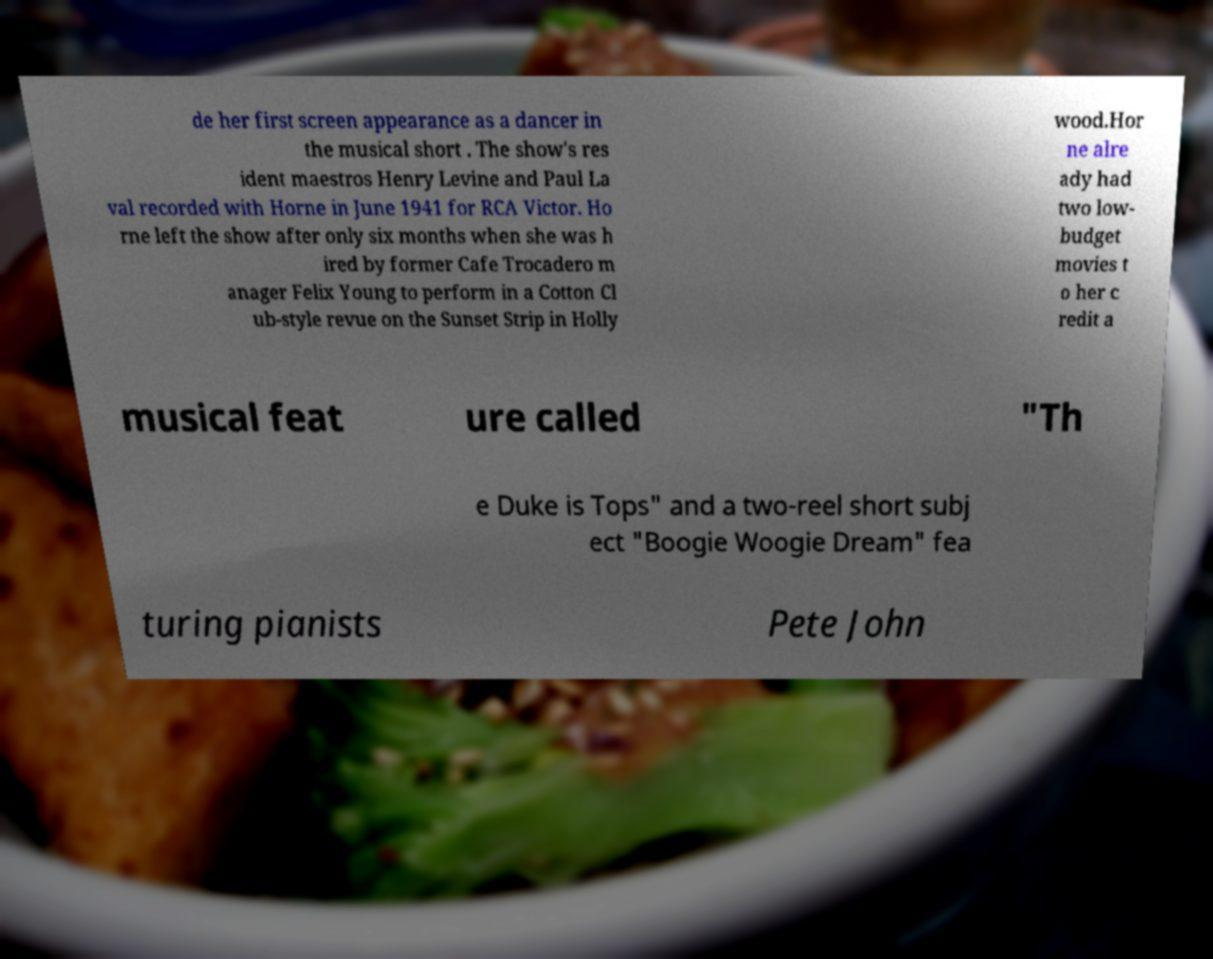I need the written content from this picture converted into text. Can you do that? de her first screen appearance as a dancer in the musical short . The show's res ident maestros Henry Levine and Paul La val recorded with Horne in June 1941 for RCA Victor. Ho rne left the show after only six months when she was h ired by former Cafe Trocadero m anager Felix Young to perform in a Cotton Cl ub-style revue on the Sunset Strip in Holly wood.Hor ne alre ady had two low- budget movies t o her c redit a musical feat ure called "Th e Duke is Tops" and a two-reel short subj ect "Boogie Woogie Dream" fea turing pianists Pete John 